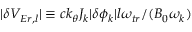Convert formula to latex. <formula><loc_0><loc_0><loc_500><loc_500>| \delta V _ { E r , l } | \equiv c k _ { \theta } J _ { k } | \delta \phi _ { k } | l \omega _ { t r } / ( B _ { 0 } \omega _ { k } )</formula> 